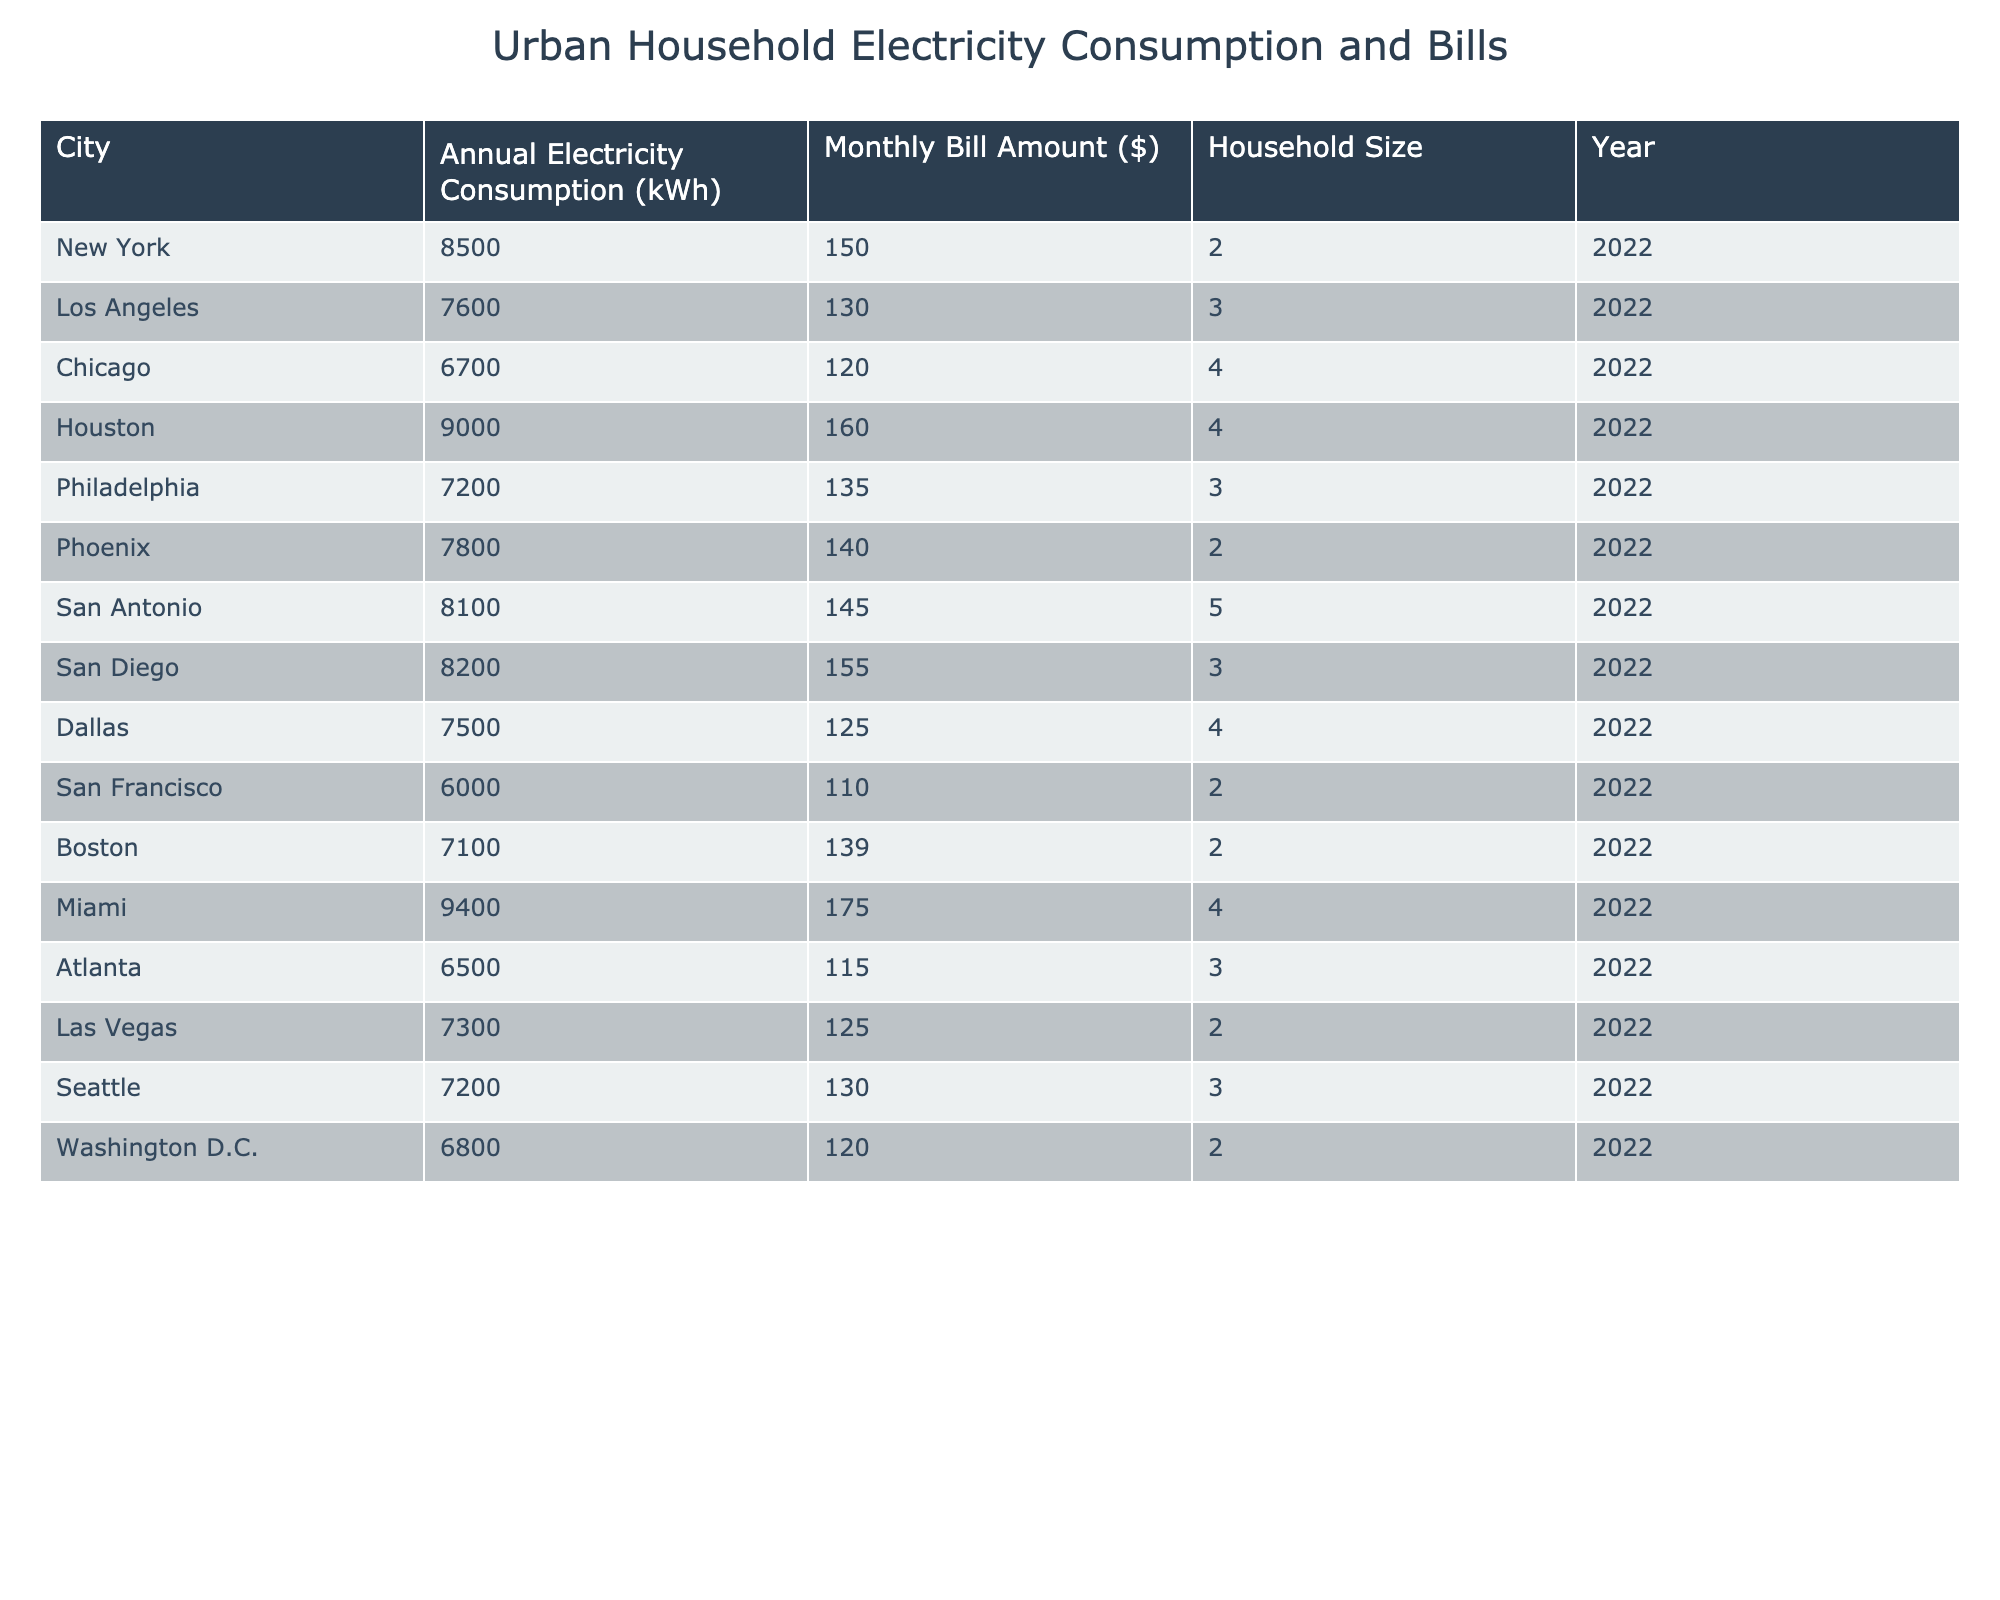What is the annual electricity consumption of Los Angeles? The table provides the data for each city, and for Los Angeles, the annual electricity consumption is directly listed as 7600 kWh.
Answer: 7600 kWh What is the monthly bill amount for Houston? The table has a specific entry for Houston, detailing the monthly bill amount, which is $160.
Answer: $160 Which city has the highest monthly bill amount? By reviewing the monthly bill amounts for each city, Miami has the highest bill at $175, compared to other cities.
Answer: Miami What is the average annual electricity consumption of all cities listed? To find the average, sum up all annual electricity consumptions: (8500 + 7600 + 6700 + 9000 + 7200 + 7800 + 8100 + 8200 + 7500 + 6000 + 7100 + 9400 + 6500 + 7300 + 7200 + 6800) = 107500 kWh. Then divide by the number of cities (16): 107500 / 16 = 6718.75 kWh.
Answer: 6718.75 kWh Is the monthly bill amount for San Francisco greater than $120? The monthly bill for San Francisco is listed as $110, which is less than $120, indicating the statement is false.
Answer: No What is the difference between the highest and lowest annual electricity consumption among the listed cities? The highest annual consumption is 9400 kWh (Miami) and the lowest is 6000 kWh (San Francisco). The difference is calculated as: 9400 - 6000 = 3400 kWh.
Answer: 3400 kWh Are there more households with a size of 4 than a size of 3 listed in the table? Counting the entries, there are 3 households of size 4 (Chicago, Houston, Miami) and 6 households of size 3 (Los Angeles, Philadelphia, San Diego, Seattle, Atlanta, and Washington D.C.). Since 6 is greater than 3, the statement is true.
Answer: Yes What percentage of the total monthly bill amounts for all cities is accounted for by the monthly bill amount of Atlanta? First, sum the monthly bill amounts: (150 + 130 + 120 + 160 + 135 + 140 + 145 + 155 + 125 + 110 + 139 + 175 + 115 + 125 + 130 + 120) = $1985. The monthly bill for Atlanta is $115. The percentage is calculated as: (115 / 1985) * 100 = 5.79%.
Answer: 5.79% Which city has the lowest household size and what is its electricity consumption? The city with the lowest household size is San Francisco, which has 2 people. Its annual electricity consumption is 6000 kWh.
Answer: San Francisco, 6000 kWh What is the trend in monthly bill amounts as household size increases? To analyze, we can track the monthly bill amounts corresponding with increasing household sizes. However, by observing the data: the bills increase from 2 to 3 household sizes, then vary as sizes increase further. This indicates no clear trend.
Answer: No clear trend 